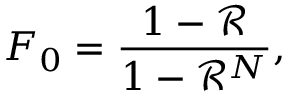<formula> <loc_0><loc_0><loc_500><loc_500>F _ { 0 } = \frac { 1 - \mathcal { R } } { 1 - \mathcal { R } ^ { N } } ,</formula> 